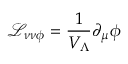Convert formula to latex. <formula><loc_0><loc_0><loc_500><loc_500>{ \mathcal { L } } _ { \nu \nu \phi } = \frac { 1 } { V _ { \Lambda } } \partial _ { \mu } \phi \,</formula> 